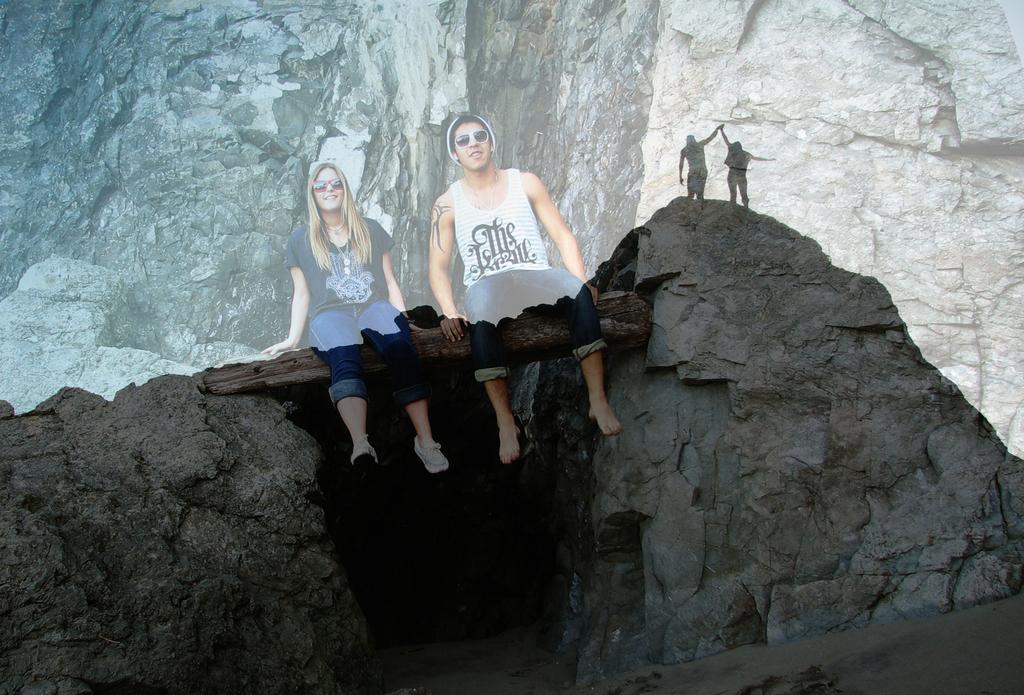Could you give a brief overview of what you see in this image? There are rocks. Between the rocks there is a wooden log. On that two persons are sitting. They are wearing goggles. In the back there is rock. Also we can see two people standing. 